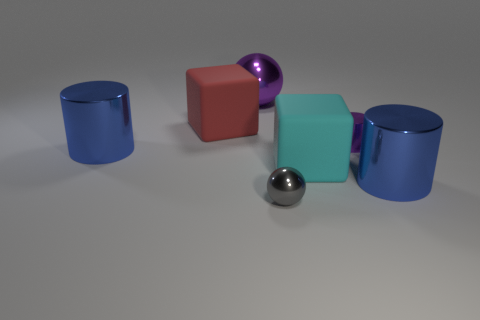There is a sphere in front of the blue metallic cylinder to the right of the tiny purple cylinder; what is its color?
Provide a succinct answer. Gray. Is the number of big spheres to the left of the large cyan thing the same as the number of big purple shiny objects to the right of the large purple metallic thing?
Your answer should be very brief. No. How many cylinders are either blue metallic objects or purple metallic objects?
Give a very brief answer. 3. What number of other things are the same material as the small ball?
Keep it short and to the point. 4. There is a small thing that is on the right side of the small gray metal thing; what shape is it?
Provide a succinct answer. Cylinder. There is a large cylinder to the right of the large shiny cylinder that is to the left of the tiny purple cylinder; what is it made of?
Provide a short and direct response. Metal. Is the number of cyan matte objects behind the small purple thing greater than the number of gray metal things?
Provide a succinct answer. No. How many other things are the same color as the small ball?
Offer a terse response. 0. The thing that is the same size as the purple metal cylinder is what shape?
Your response must be concise. Sphere. How many things are behind the big cylinder that is right of the large purple thing that is behind the tiny gray thing?
Provide a succinct answer. 5. 